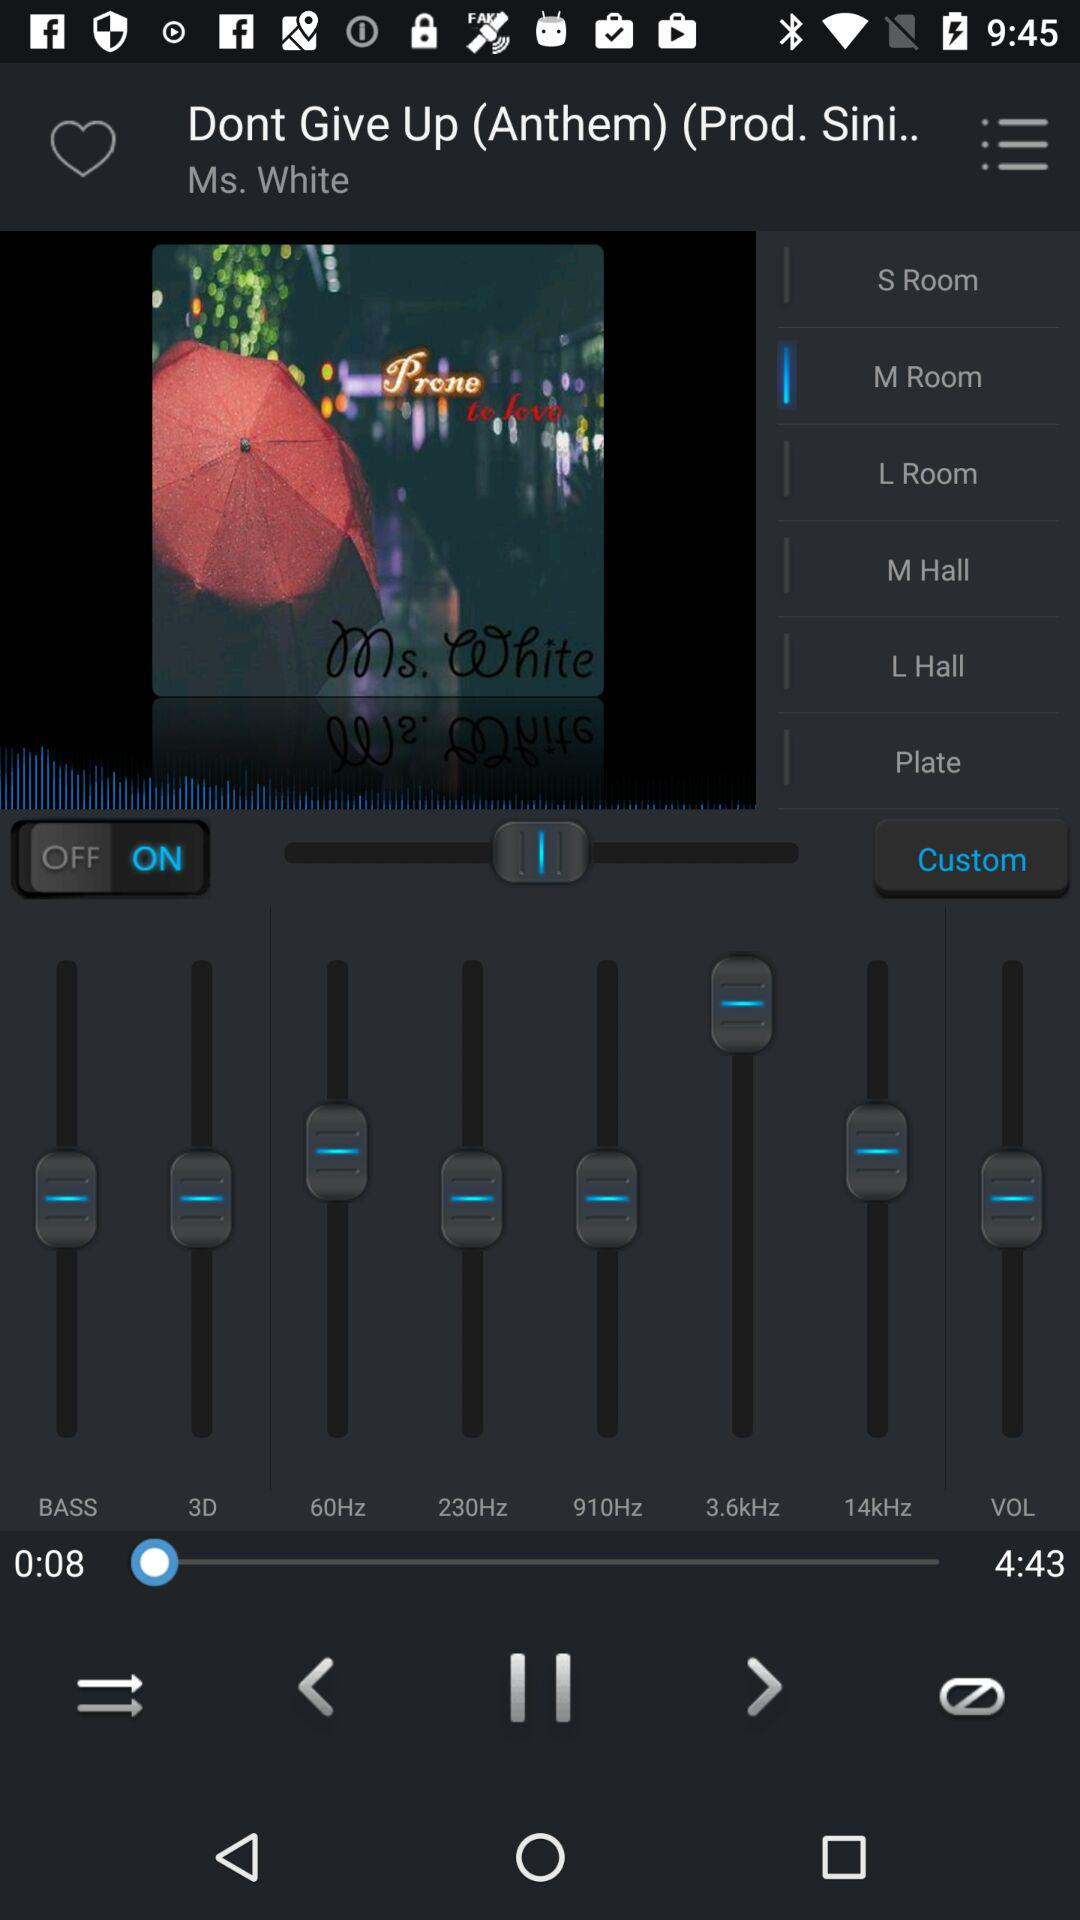Which option is selected? The selected option is "M Room". 